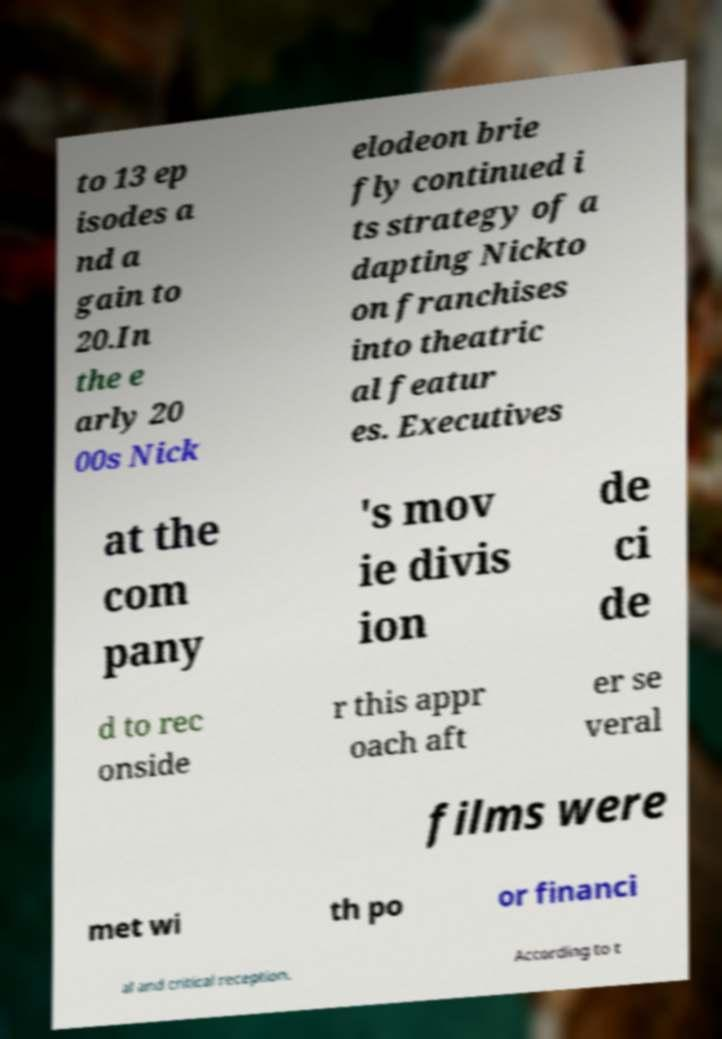I need the written content from this picture converted into text. Can you do that? to 13 ep isodes a nd a gain to 20.In the e arly 20 00s Nick elodeon brie fly continued i ts strategy of a dapting Nickto on franchises into theatric al featur es. Executives at the com pany 's mov ie divis ion de ci de d to rec onside r this appr oach aft er se veral films were met wi th po or financi al and critical reception. According to t 